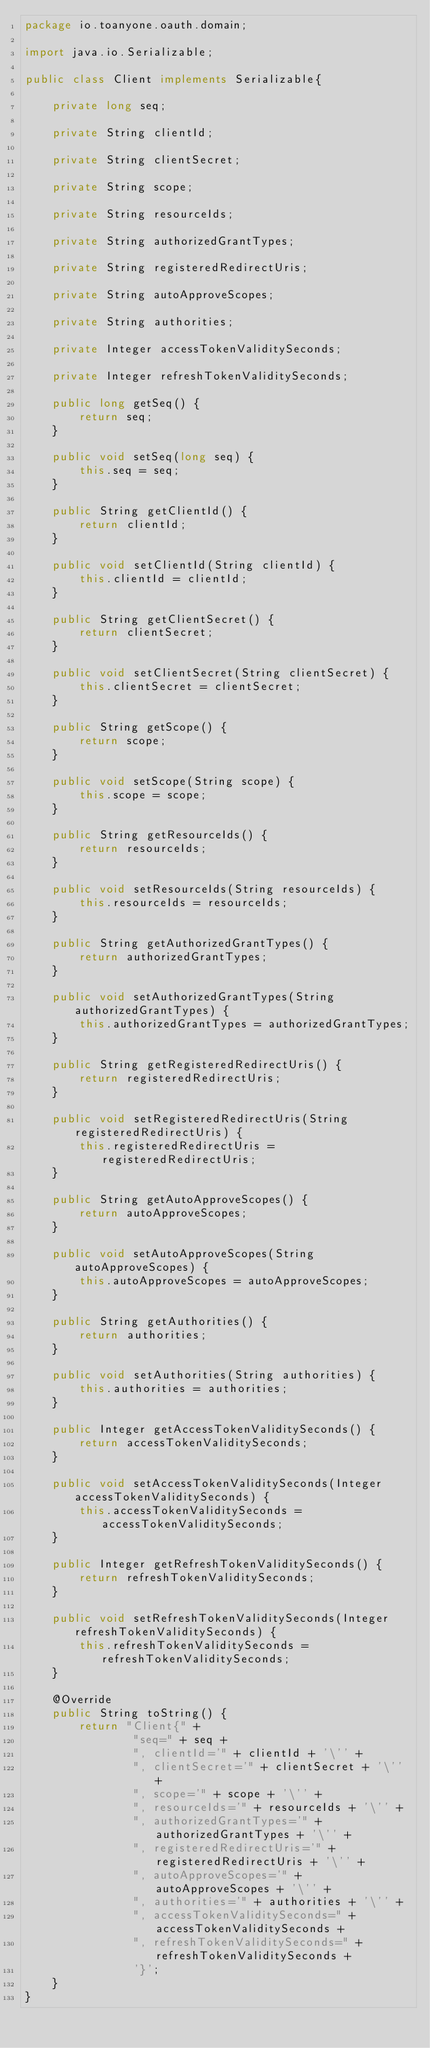<code> <loc_0><loc_0><loc_500><loc_500><_Java_>package io.toanyone.oauth.domain;

import java.io.Serializable;

public class Client implements Serializable{

    private long seq;

    private String clientId;

    private String clientSecret;

    private String scope;

    private String resourceIds;

    private String authorizedGrantTypes;

    private String registeredRedirectUris;

    private String autoApproveScopes;

    private String authorities;

    private Integer accessTokenValiditySeconds;

    private Integer refreshTokenValiditySeconds;

    public long getSeq() {
        return seq;
    }

    public void setSeq(long seq) {
        this.seq = seq;
    }

    public String getClientId() {
        return clientId;
    }

    public void setClientId(String clientId) {
        this.clientId = clientId;
    }

    public String getClientSecret() {
        return clientSecret;
    }

    public void setClientSecret(String clientSecret) {
        this.clientSecret = clientSecret;
    }

    public String getScope() {
        return scope;
    }

    public void setScope(String scope) {
        this.scope = scope;
    }

    public String getResourceIds() {
        return resourceIds;
    }

    public void setResourceIds(String resourceIds) {
        this.resourceIds = resourceIds;
    }

    public String getAuthorizedGrantTypes() {
        return authorizedGrantTypes;
    }

    public void setAuthorizedGrantTypes(String authorizedGrantTypes) {
        this.authorizedGrantTypes = authorizedGrantTypes;
    }

    public String getRegisteredRedirectUris() {
        return registeredRedirectUris;
    }

    public void setRegisteredRedirectUris(String registeredRedirectUris) {
        this.registeredRedirectUris = registeredRedirectUris;
    }

    public String getAutoApproveScopes() {
        return autoApproveScopes;
    }

    public void setAutoApproveScopes(String autoApproveScopes) {
        this.autoApproveScopes = autoApproveScopes;
    }

    public String getAuthorities() {
        return authorities;
    }

    public void setAuthorities(String authorities) {
        this.authorities = authorities;
    }

    public Integer getAccessTokenValiditySeconds() {
        return accessTokenValiditySeconds;
    }

    public void setAccessTokenValiditySeconds(Integer accessTokenValiditySeconds) {
        this.accessTokenValiditySeconds = accessTokenValiditySeconds;
    }

    public Integer getRefreshTokenValiditySeconds() {
        return refreshTokenValiditySeconds;
    }

    public void setRefreshTokenValiditySeconds(Integer refreshTokenValiditySeconds) {
        this.refreshTokenValiditySeconds = refreshTokenValiditySeconds;
    }

    @Override
    public String toString() {
        return "Client{" +
                "seq=" + seq +
                ", clientId='" + clientId + '\'' +
                ", clientSecret='" + clientSecret + '\'' +
                ", scope='" + scope + '\'' +
                ", resourceIds='" + resourceIds + '\'' +
                ", authorizedGrantTypes='" + authorizedGrantTypes + '\'' +
                ", registeredRedirectUris='" + registeredRedirectUris + '\'' +
                ", autoApproveScopes='" + autoApproveScopes + '\'' +
                ", authorities='" + authorities + '\'' +
                ", accessTokenValiditySeconds=" + accessTokenValiditySeconds +
                ", refreshTokenValiditySeconds=" + refreshTokenValiditySeconds +
                '}';
    }
}
</code> 